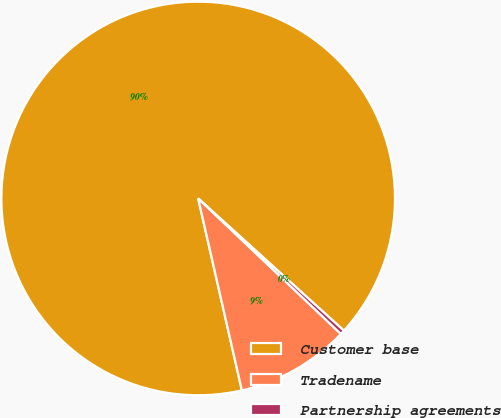Convert chart to OTSL. <chart><loc_0><loc_0><loc_500><loc_500><pie_chart><fcel>Customer base<fcel>Tradename<fcel>Partnership agreements<nl><fcel>90.29%<fcel>9.35%<fcel>0.36%<nl></chart> 